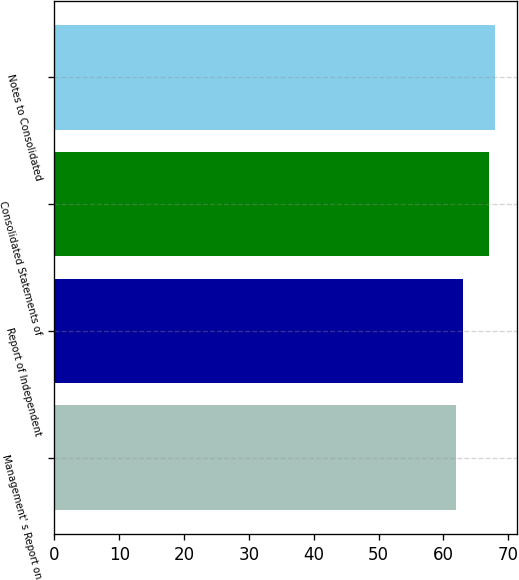Convert chart to OTSL. <chart><loc_0><loc_0><loc_500><loc_500><bar_chart><fcel>Management' s Report on<fcel>Report of Independent<fcel>Consolidated Statements of<fcel>Notes to Consolidated<nl><fcel>62<fcel>63<fcel>67<fcel>68<nl></chart> 